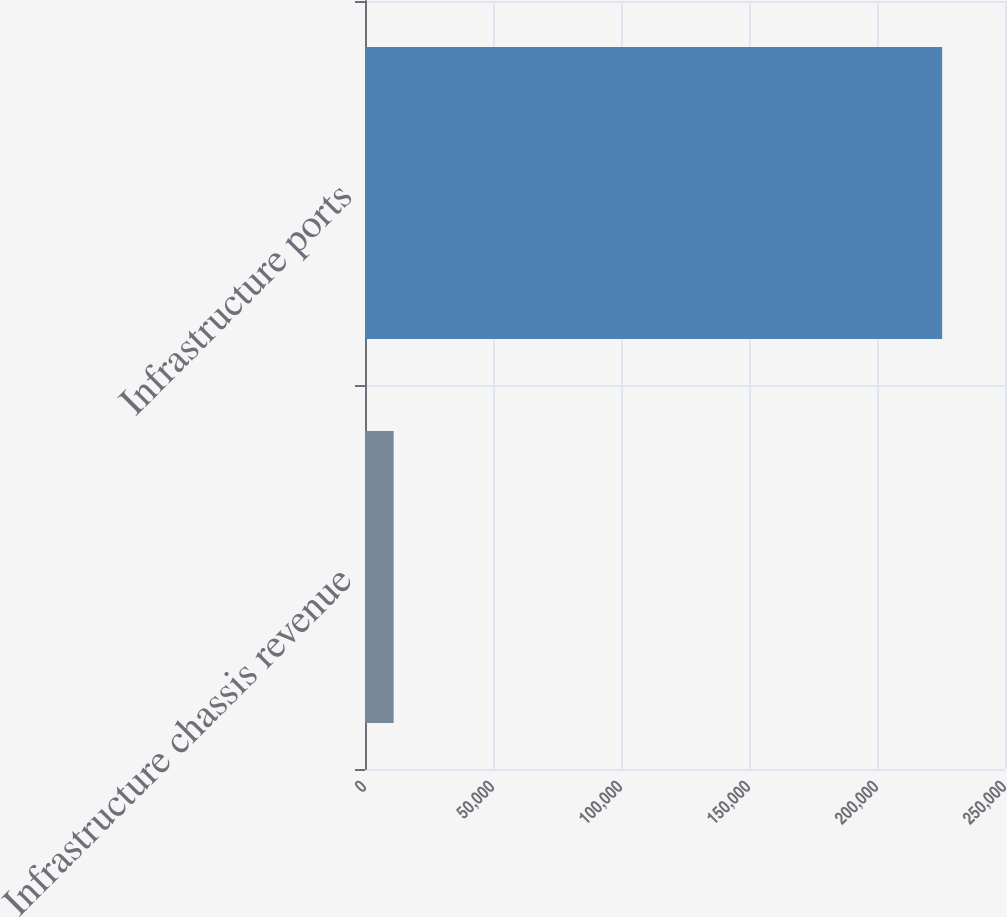Convert chart to OTSL. <chart><loc_0><loc_0><loc_500><loc_500><bar_chart><fcel>Infrastructure chassis revenue<fcel>Infrastructure ports<nl><fcel>11195<fcel>225452<nl></chart> 